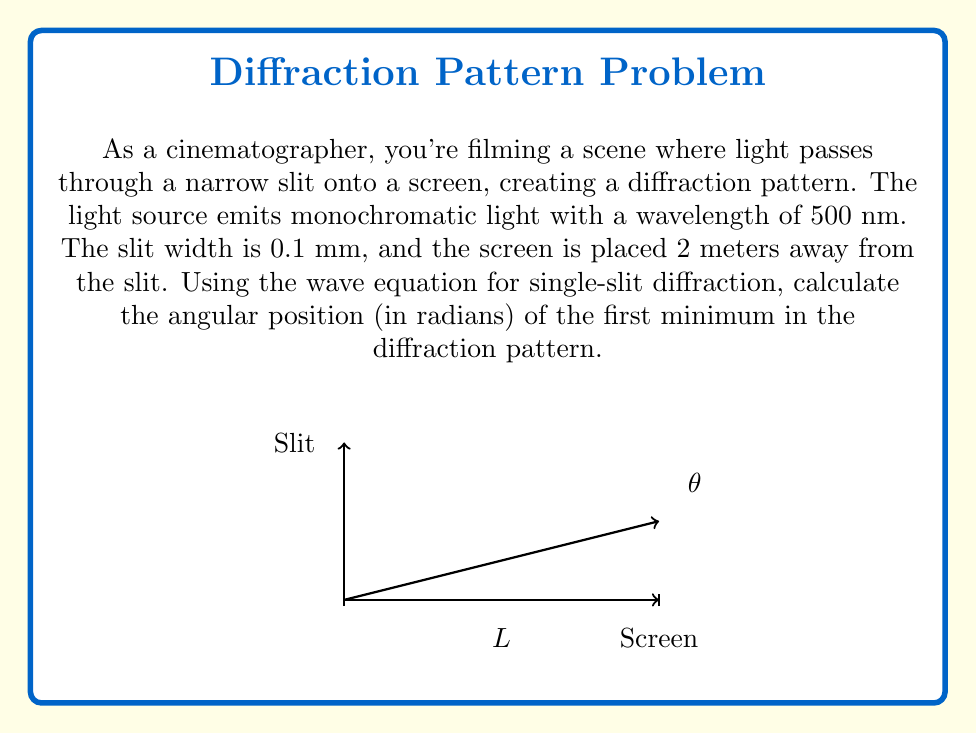Can you solve this math problem? Let's approach this step-by-step using the wave equation for single-slit diffraction:

1) The equation for the angular position of minima in a single-slit diffraction pattern is:

   $$a \sin \theta = m\lambda$$

   where:
   $a$ is the slit width
   $\theta$ is the angle to the minimum
   $m$ is the order of the minimum (1, 2, 3, ...)
   $\lambda$ is the wavelength of light

2) We're asked to find the first minimum, so $m = 1$

3) Given:
   $a = 0.1 \text{ mm} = 1 \times 10^{-4} \text{ m}$
   $\lambda = 500 \text{ nm} = 5 \times 10^{-7} \text{ m}$

4) Substituting into the equation:

   $$(1 \times 10^{-4}) \sin \theta = 1(5 \times 10^{-7})$$

5) Solving for $\theta$:

   $$\sin \theta = \frac{5 \times 10^{-7}}{1 \times 10^{-4}} = 5 \times 10^{-3}$$

6) Taking the inverse sine (arcsin) of both sides:

   $$\theta = \arcsin(5 \times 10^{-3})$$

7) Using a calculator or computer:

   $$\theta \approx 0.005 \text{ radians}$$

This angle represents the position of the first minimum in the diffraction pattern, measured from the central maximum.
Answer: 0.005 radians 